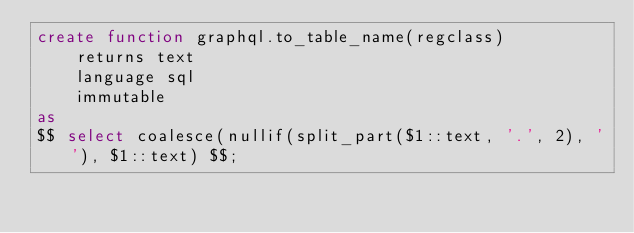<code> <loc_0><loc_0><loc_500><loc_500><_SQL_>create function graphql.to_table_name(regclass)
    returns text
    language sql
    immutable
as
$$ select coalesce(nullif(split_part($1::text, '.', 2), ''), $1::text) $$;
</code> 